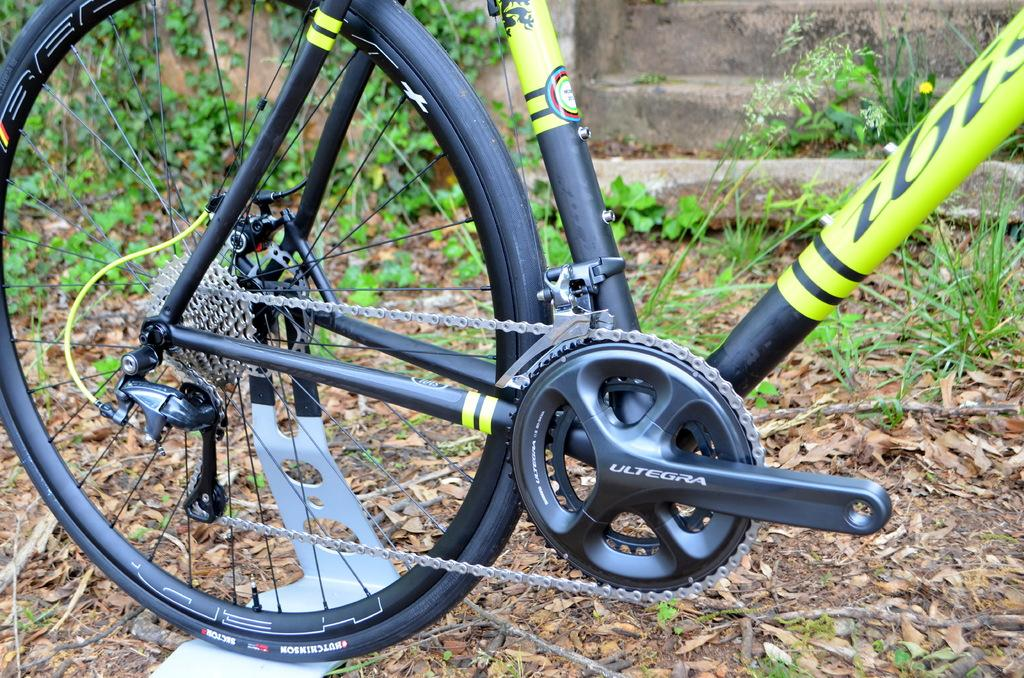What is on the ground in the image? There is a bicycle on the ground. What can be seen in the background of the image? There are plants and a wall in the background of the image. What else is on the ground besides the bicycle? There are sticks and leaves on the ground. What type of lumber can be seen in the image? There is no lumber present in the image. Can you tell me how many noses are visible in the image? There are no noses visible in the image. 